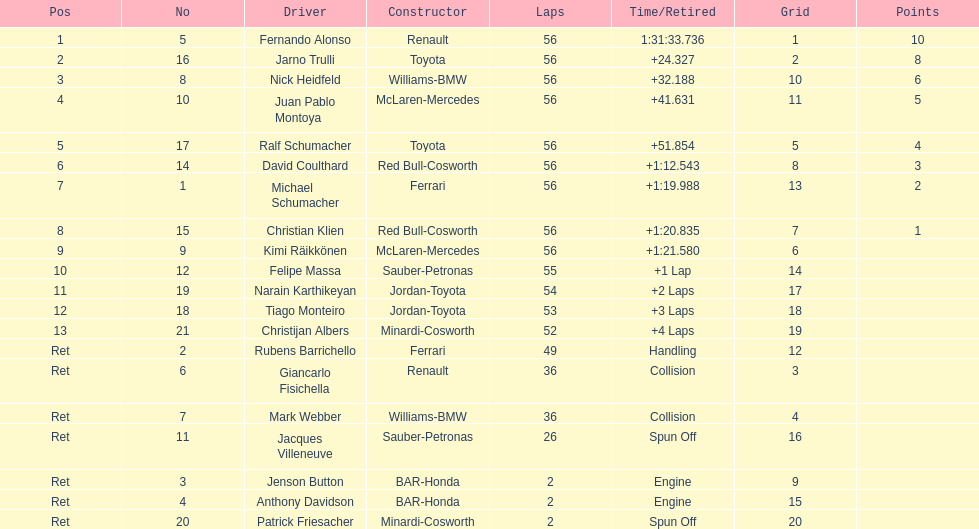Jarno trulli was not french but what nationality? Italian. 